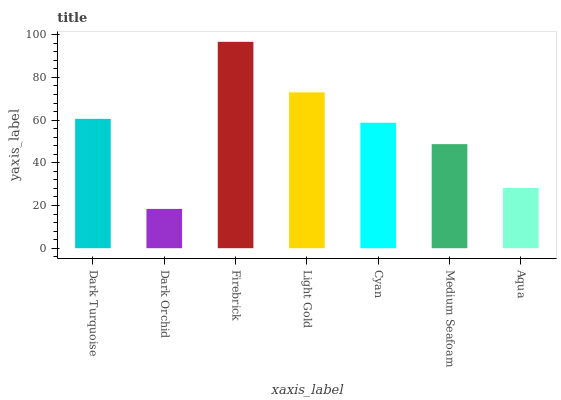Is Dark Orchid the minimum?
Answer yes or no. Yes. Is Firebrick the maximum?
Answer yes or no. Yes. Is Firebrick the minimum?
Answer yes or no. No. Is Dark Orchid the maximum?
Answer yes or no. No. Is Firebrick greater than Dark Orchid?
Answer yes or no. Yes. Is Dark Orchid less than Firebrick?
Answer yes or no. Yes. Is Dark Orchid greater than Firebrick?
Answer yes or no. No. Is Firebrick less than Dark Orchid?
Answer yes or no. No. Is Cyan the high median?
Answer yes or no. Yes. Is Cyan the low median?
Answer yes or no. Yes. Is Aqua the high median?
Answer yes or no. No. Is Dark Turquoise the low median?
Answer yes or no. No. 